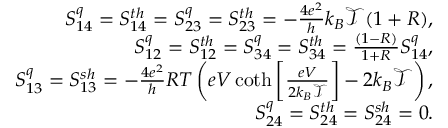Convert formula to latex. <formula><loc_0><loc_0><loc_500><loc_500>\begin{array} { r } { S _ { 1 4 } ^ { q } = { S _ { 1 4 } ^ { t h } } = S _ { 2 3 } ^ { q } = { S _ { 2 3 } ^ { t h } } = - \frac { 4 e ^ { 2 } } { h } k _ { B } \mathcal { T } ( 1 + R ) , } \\ { S _ { 1 2 } ^ { q } = { S _ { 1 2 } ^ { t h } } = S _ { 3 4 } ^ { q } = { S _ { 3 4 } ^ { t h } } = \frac { ( 1 - R ) } { 1 + R } S _ { 1 4 } ^ { q } , } \\ { S _ { 1 3 } ^ { q } = { S _ { 1 3 } ^ { s h } } = - \frac { 4 e ^ { 2 } } { h } R T \left ( e V \coth \left [ \frac { e V } { 2 k _ { B } \mathcal { T } } \right ] - 2 k _ { B } \mathcal { T } \right ) , } \\ { { S _ { 2 4 } ^ { q } = S _ { 2 4 } ^ { t h } = S _ { 2 4 } ^ { s h } = 0 . } } \end{array}</formula> 